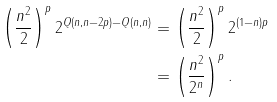<formula> <loc_0><loc_0><loc_500><loc_500>\left ( \frac { n ^ { 2 } } { 2 } \right ) ^ { p } 2 ^ { Q ( n , n - 2 p ) - Q ( n , n ) } & = \left ( \frac { n ^ { 2 } } { 2 } \right ) ^ { p } 2 ^ { ( 1 - n ) p } \\ & = \left ( \frac { n ^ { 2 } } { 2 ^ { n } } \right ) ^ { p } .</formula> 